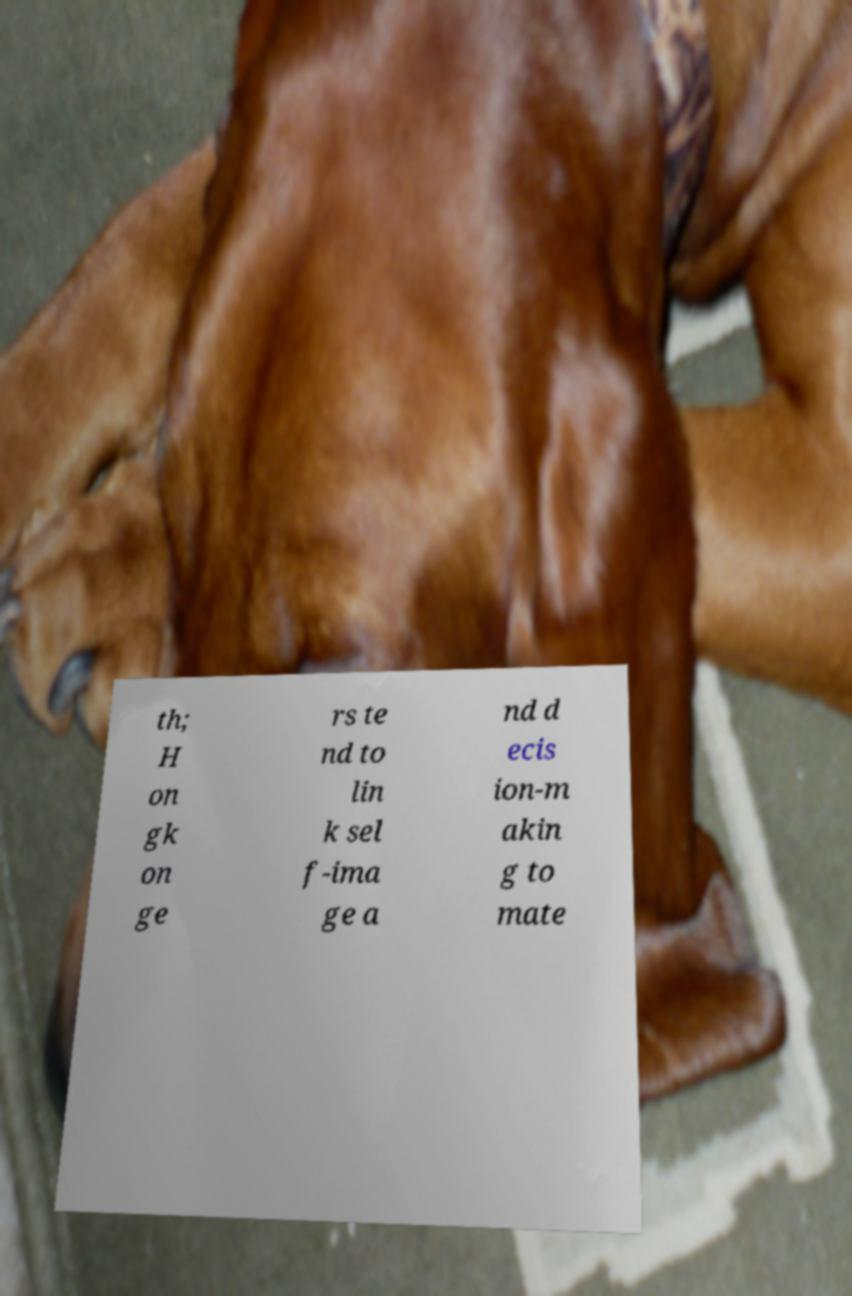Please identify and transcribe the text found in this image. th; H on gk on ge rs te nd to lin k sel f-ima ge a nd d ecis ion-m akin g to mate 